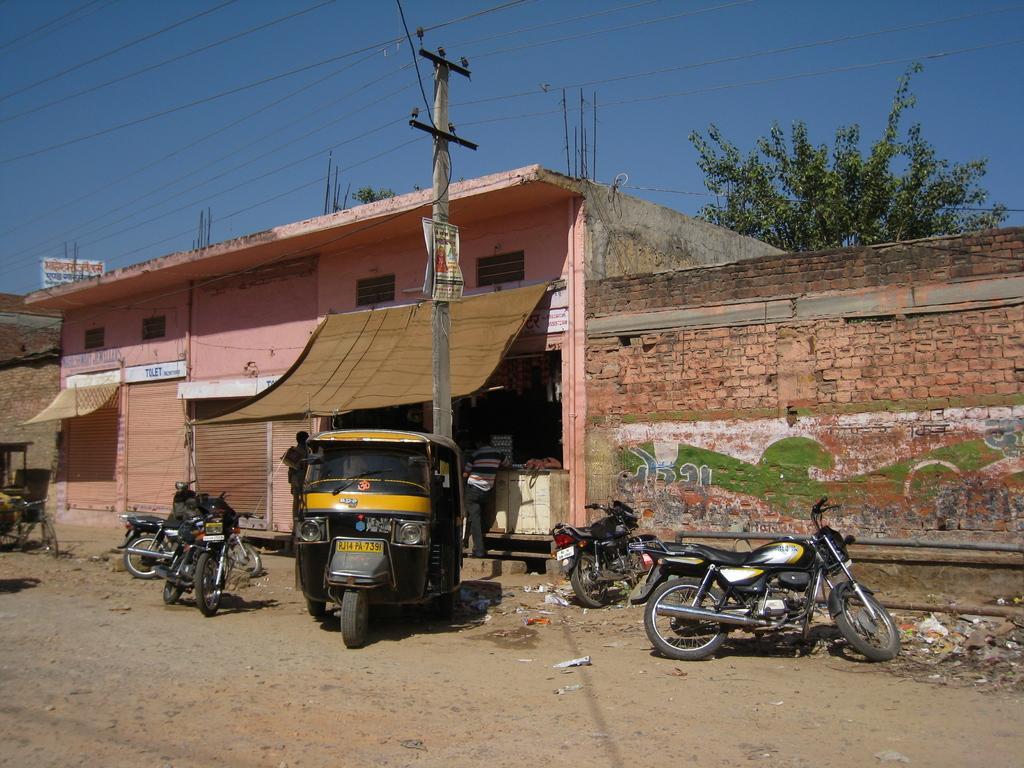Could you give a brief overview of what you see in this image? In this image, we can see some bikes and there is a black color auto, we can see some shops, there is an electric pole, we can see the wall, at the top there is a blue sky. 